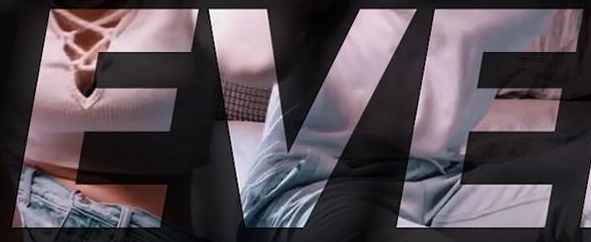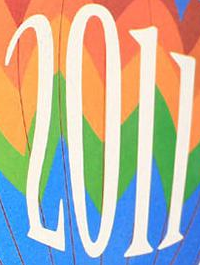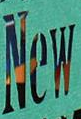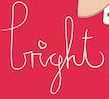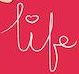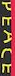Read the text content from these images in order, separated by a semicolon. EVE; 2011; New; light; life; PEACE 